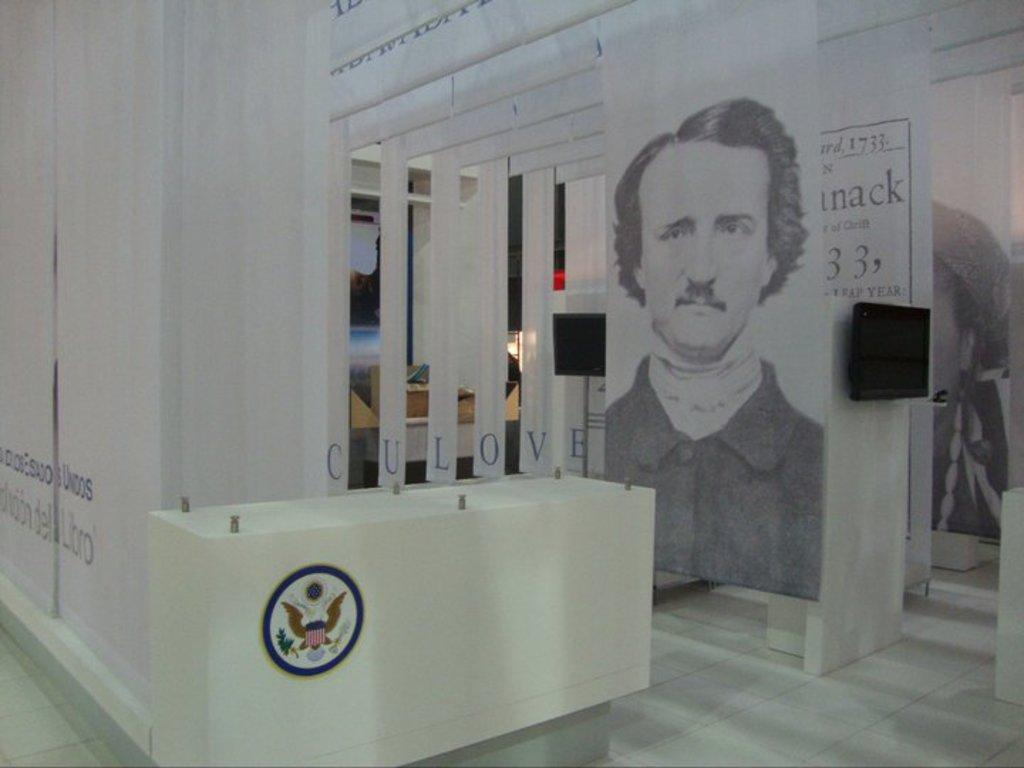What is the color of the table in the image? The table in the image is white. Are there any distinguishing features on the table? Yes, the table has a logo on it. What can be seen behind the table? There are posters behind the table. What is the color of the floor in the image? The floor is white in color. Is there a can of soda sitting in the quicksand near the table in the image? There is no quicksand or can of soda present in the image. What type of throne is visible in the image? There is no throne present in the image. 